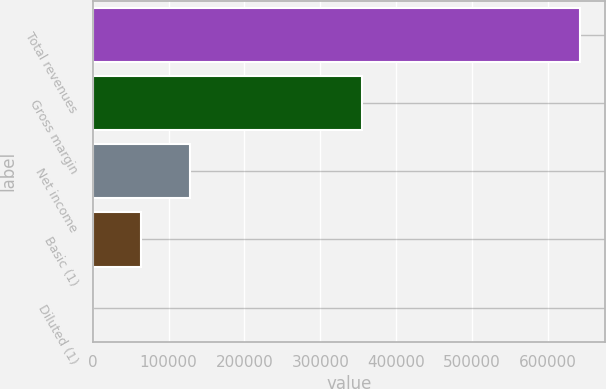Convert chart. <chart><loc_0><loc_0><loc_500><loc_500><bar_chart><fcel>Total revenues<fcel>Gross margin<fcel>Net income<fcel>Basic (1)<fcel>Diluted (1)<nl><fcel>642901<fcel>354434<fcel>128581<fcel>64290.5<fcel>0.43<nl></chart> 